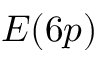Convert formula to latex. <formula><loc_0><loc_0><loc_500><loc_500>E ( 6 p )</formula> 